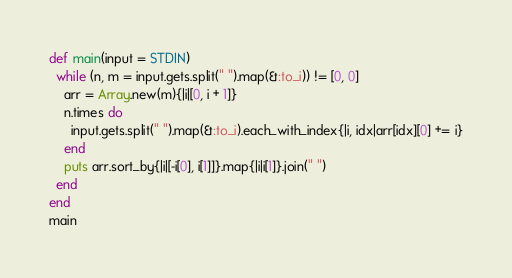Convert code to text. <code><loc_0><loc_0><loc_500><loc_500><_Ruby_>def main(input = STDIN)
  while (n, m = input.gets.split(" ").map(&:to_i)) != [0, 0]
    arr = Array.new(m){|i|[0, i + 1]}
    n.times do
      input.gets.split(" ").map(&:to_i).each_with_index{|i, idx|arr[idx][0] += i}
    end
    puts arr.sort_by{|i|[-i[0], i[1]]}.map{|i|i[1]}.join(" ")
  end
end
main</code> 